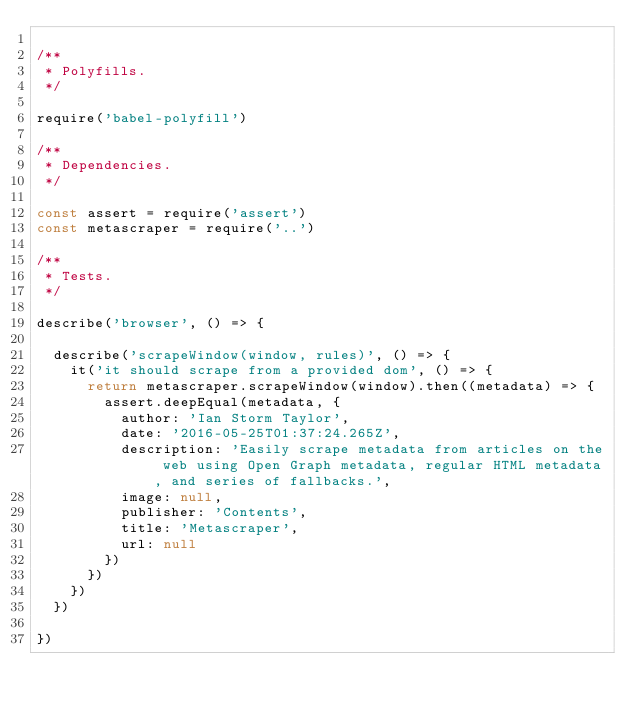<code> <loc_0><loc_0><loc_500><loc_500><_JavaScript_>
/**
 * Polyfills.
 */

require('babel-polyfill')

/**
 * Dependencies.
 */

const assert = require('assert')
const metascraper = require('..')

/**
 * Tests.
 */

describe('browser', () => {

  describe('scrapeWindow(window, rules)', () => {
    it('it should scrape from a provided dom', () => {
      return metascraper.scrapeWindow(window).then((metadata) => {
        assert.deepEqual(metadata, {
          author: 'Ian Storm Taylor',
          date: '2016-05-25T01:37:24.265Z',
          description: 'Easily scrape metadata from articles on the web using Open Graph metadata, regular HTML metadata, and series of fallbacks.',
          image: null,
          publisher: 'Contents',
          title: 'Metascraper',
          url: null
        })
      })
    })
  })

})
</code> 